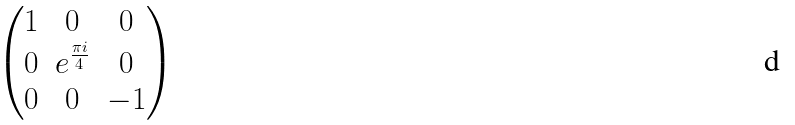<formula> <loc_0><loc_0><loc_500><loc_500>\begin{pmatrix} 1 & 0 & 0 \\ 0 & e ^ { \frac { \pi i } { 4 } } & 0 \\ 0 & 0 & - 1 \\ \end{pmatrix}</formula> 